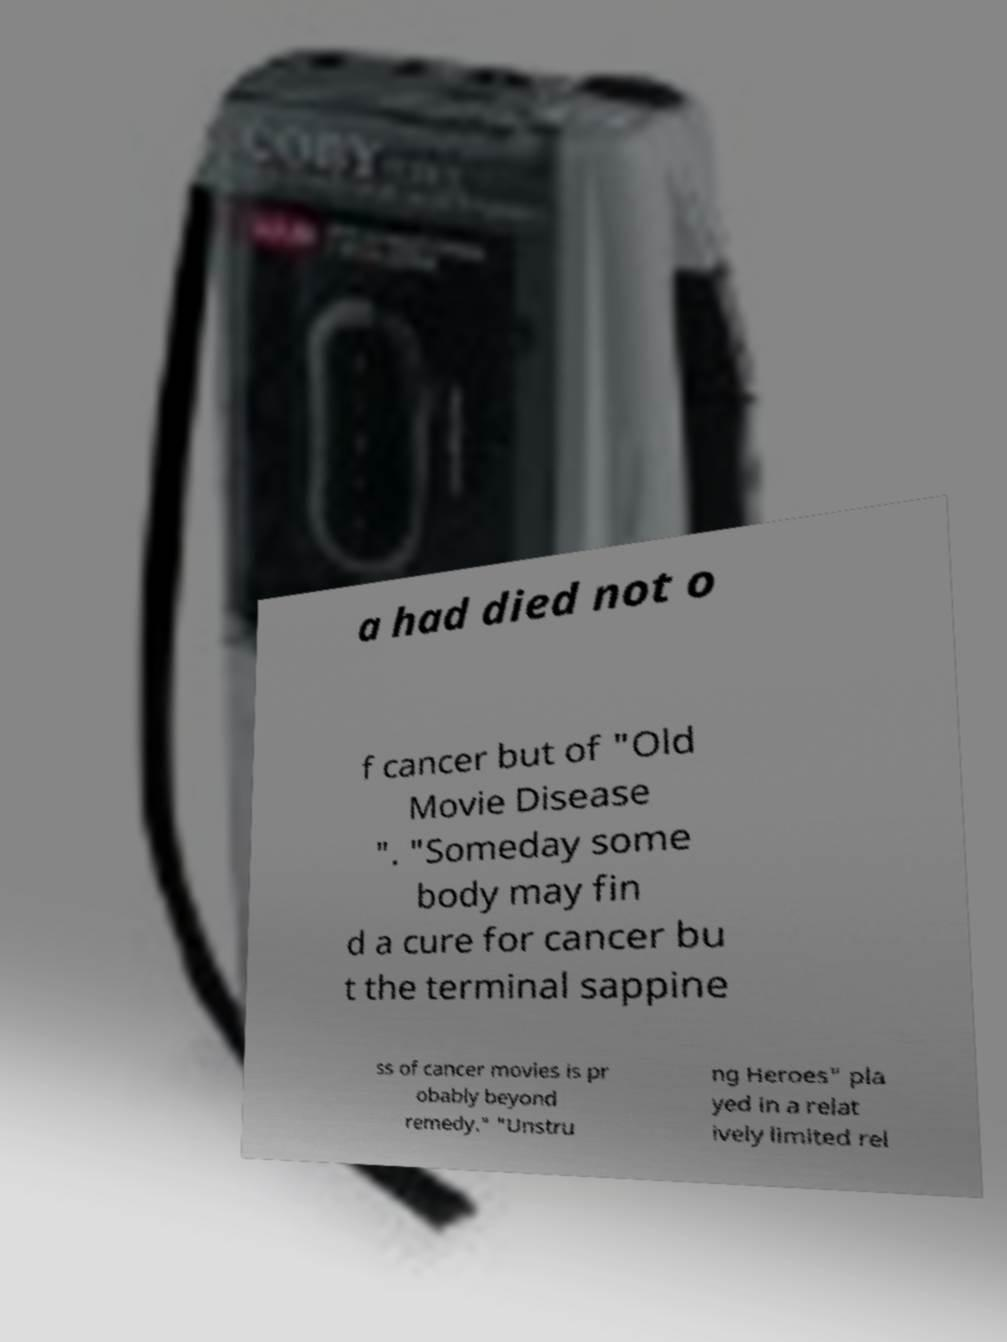Could you extract and type out the text from this image? a had died not o f cancer but of "Old Movie Disease ". "Someday some body may fin d a cure for cancer bu t the terminal sappine ss of cancer movies is pr obably beyond remedy." "Unstru ng Heroes" pla yed in a relat ively limited rel 